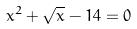Convert formula to latex. <formula><loc_0><loc_0><loc_500><loc_500>x ^ { 2 } + \sqrt { x } - 1 4 = 0</formula> 